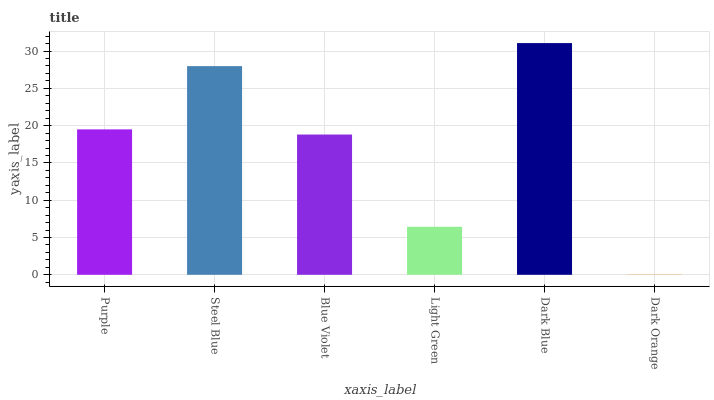Is Steel Blue the minimum?
Answer yes or no. No. Is Steel Blue the maximum?
Answer yes or no. No. Is Steel Blue greater than Purple?
Answer yes or no. Yes. Is Purple less than Steel Blue?
Answer yes or no. Yes. Is Purple greater than Steel Blue?
Answer yes or no. No. Is Steel Blue less than Purple?
Answer yes or no. No. Is Purple the high median?
Answer yes or no. Yes. Is Blue Violet the low median?
Answer yes or no. Yes. Is Dark Blue the high median?
Answer yes or no. No. Is Dark Orange the low median?
Answer yes or no. No. 